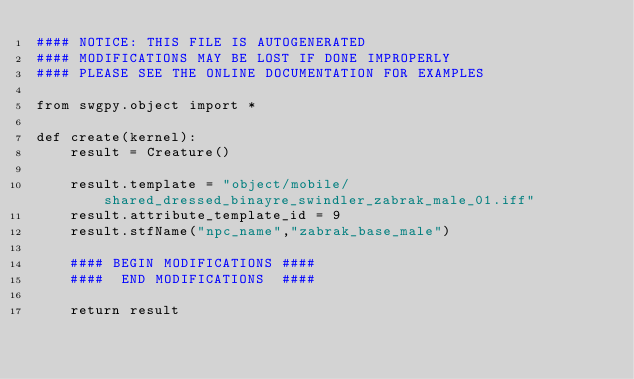<code> <loc_0><loc_0><loc_500><loc_500><_Python_>#### NOTICE: THIS FILE IS AUTOGENERATED
#### MODIFICATIONS MAY BE LOST IF DONE IMPROPERLY
#### PLEASE SEE THE ONLINE DOCUMENTATION FOR EXAMPLES

from swgpy.object import *	

def create(kernel):
	result = Creature()

	result.template = "object/mobile/shared_dressed_binayre_swindler_zabrak_male_01.iff"
	result.attribute_template_id = 9
	result.stfName("npc_name","zabrak_base_male")		
	
	#### BEGIN MODIFICATIONS ####
	####  END MODIFICATIONS  ####
	
	return result</code> 